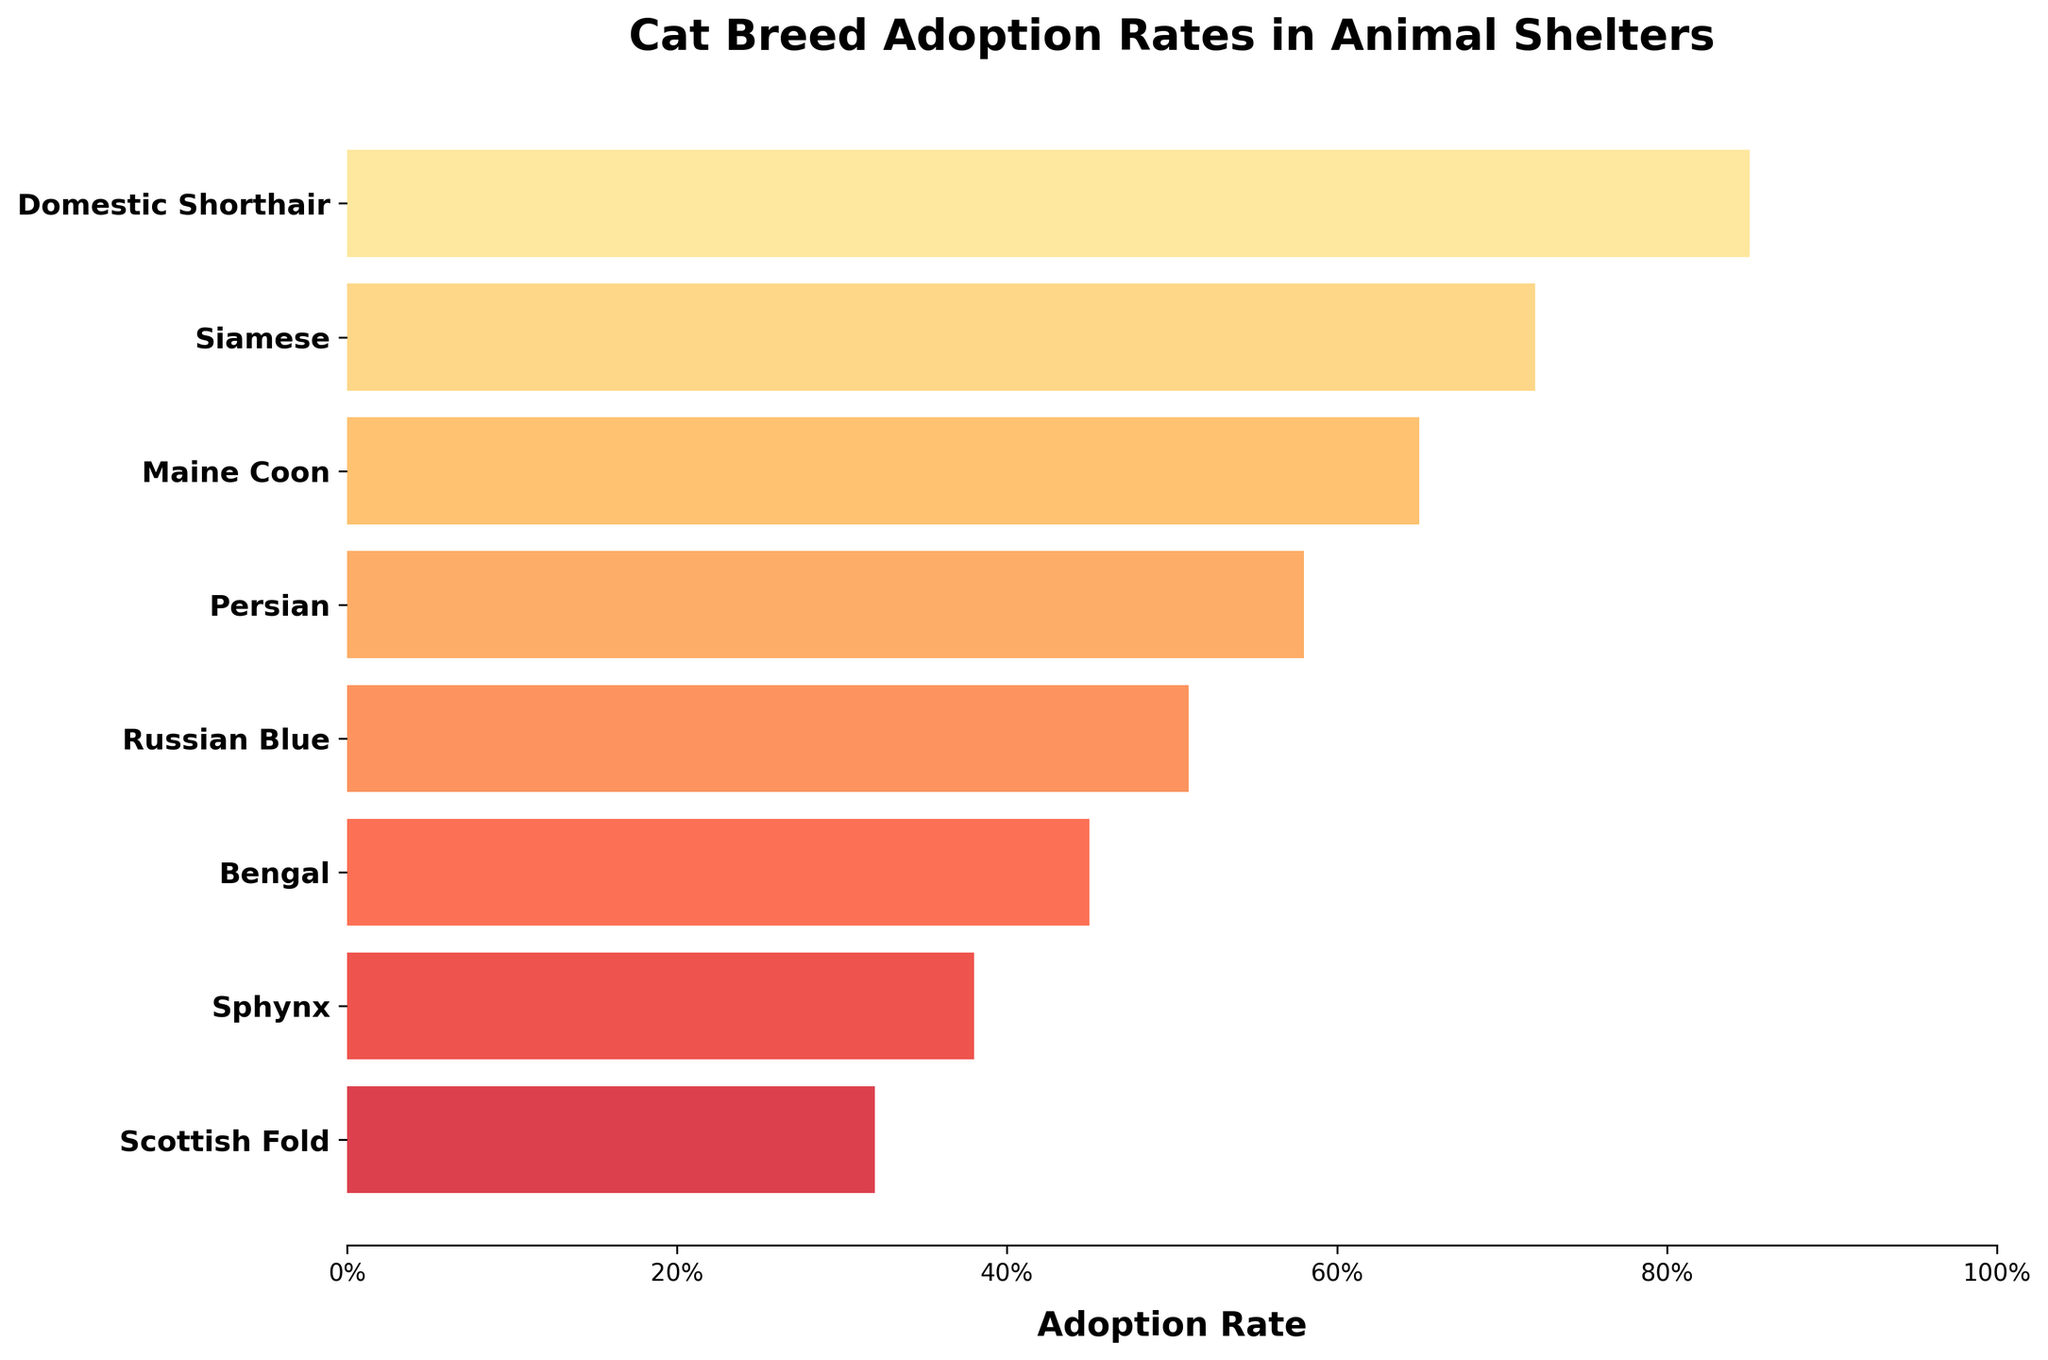What is the title of the chart? The title of the chart is located at the top and usually describes the theme or subject matter of the figure. In this case, it is "Cat Breed Adoption Rates in Animal Shelters".
Answer: Cat Breed Adoption Rates in Animal Shelters What is the adoption rate of Persian cats? Locate Persian in the list of cat breeds on the y-axis and follow its associated bar to the x-axis where the adoption rate is labeled. It shows 58%.
Answer: 58% Which cat breed has the lowest adoption rate? Examine all bars and their corresponding labels, the Sphynx has the smallest bar with an adoption rate of 32%.
Answer: Scottish Fold How many cat breeds have an adoption rate greater than 50%? Check each bar and its associated adoption rate, count how many of these rates exceed 50%. The breeds are Domestic Shorthair, Siamese, Maine Coon, Persian, and Russian Blue.
Answer: 5 What is the difference in adoption rates between Domestic Shorthairs and Bengals? Locate the adoption rates of Domestic Shorthairs (85%) and Bengals (45%). Subtract the Bengal rate from the Domestic Shorthair rate: 85% - 45% = 40%.
Answer: 40% Which cat breed has an adoption rate closer to 45%? First, identify the Bengal's adoption rate of 45%, then compare it with adoption rates of other breeds. The Russian Blue (51%) and Bengal (45%) are closest, but Bengal is exactly 45%.
Answer: Bengal What percentage of cat breeds have an adoption rate over 70%? Count the total number of breeds (8) and determine how many have rates over 70% (Domestic Shorthair and Siamese, so 2). Calculate the percentage: (2/8) * 100 = 25%.
Answer: 25% Between Siamese and Russian Blue cats, which has a higher adoption rate and by how much? Compare the adoption rates: Siamese (72%) and Russian Blue (51%), and subtract the lower from the higher: 72% - 51% = 21%.
Answer: Siamese by 21% What is the median adoption rate of the cat breeds? List all adoption rates in numerical order (32%, 38%, 45%, 51%, 58%, 65%, 72%, 85%) and find the middle value(s). For an even number of data points, take the average of the middle two (58% and 51%), which is (58 + 51) / 2 = 54.5%.
Answer: 54.5% What is the range of adoption rates in the chart? Determine the highest (Domestic Shorthair - 85%) and lowest (Scottish Fold - 32%) adoption rates and subtract the lowest from the highest: 85% - 32% = 53%.
Answer: 53% 